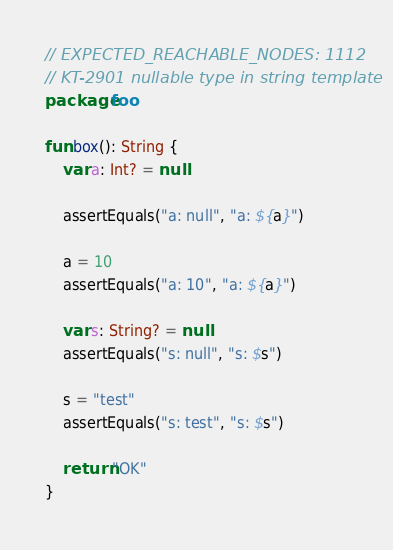<code> <loc_0><loc_0><loc_500><loc_500><_Kotlin_>// EXPECTED_REACHABLE_NODES: 1112
// KT-2901 nullable type in string template
package foo

fun box(): String {
    var a: Int? = null

    assertEquals("a: null", "a: ${a}")

    a = 10
    assertEquals("a: 10", "a: ${a}")

    var s: String? = null
    assertEquals("s: null", "s: $s")

    s = "test"
    assertEquals("s: test", "s: $s")

    return "OK"
}</code> 